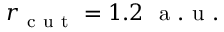Convert formula to latex. <formula><loc_0><loc_0><loc_500><loc_500>r _ { c u t } = 1 . 2 \ a . u .</formula> 